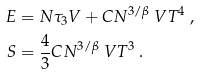Convert formula to latex. <formula><loc_0><loc_0><loc_500><loc_500>E & = N \tau _ { 3 } V + C N ^ { 3 / \beta } \ V T ^ { 4 } \ , \\ S & = \frac { 4 } { 3 } C N ^ { 3 / \beta } \ V T ^ { 3 } \ .</formula> 